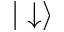Convert formula to latex. <formula><loc_0><loc_0><loc_500><loc_500>| \downarrow \rangle</formula> 